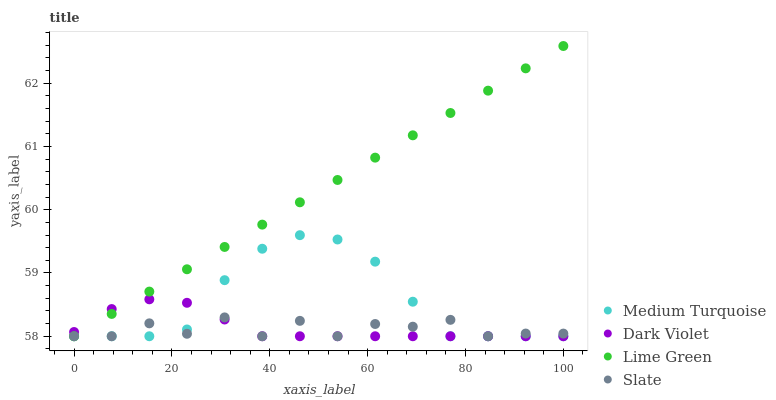Does Slate have the minimum area under the curve?
Answer yes or no. Yes. Does Lime Green have the maximum area under the curve?
Answer yes or no. Yes. Does Dark Violet have the minimum area under the curve?
Answer yes or no. No. Does Dark Violet have the maximum area under the curve?
Answer yes or no. No. Is Lime Green the smoothest?
Answer yes or no. Yes. Is Slate the roughest?
Answer yes or no. Yes. Is Dark Violet the smoothest?
Answer yes or no. No. Is Dark Violet the roughest?
Answer yes or no. No. Does Slate have the lowest value?
Answer yes or no. Yes. Does Lime Green have the highest value?
Answer yes or no. Yes. Does Dark Violet have the highest value?
Answer yes or no. No. Does Lime Green intersect Medium Turquoise?
Answer yes or no. Yes. Is Lime Green less than Medium Turquoise?
Answer yes or no. No. Is Lime Green greater than Medium Turquoise?
Answer yes or no. No. 